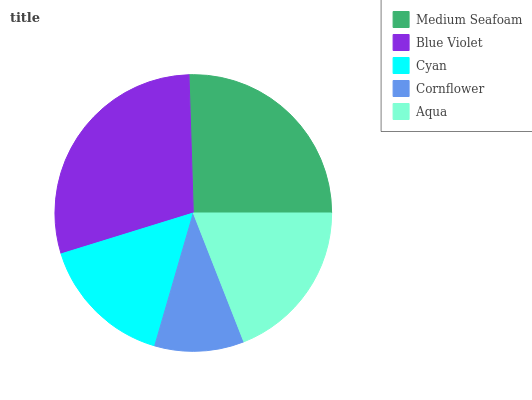Is Cornflower the minimum?
Answer yes or no. Yes. Is Blue Violet the maximum?
Answer yes or no. Yes. Is Cyan the minimum?
Answer yes or no. No. Is Cyan the maximum?
Answer yes or no. No. Is Blue Violet greater than Cyan?
Answer yes or no. Yes. Is Cyan less than Blue Violet?
Answer yes or no. Yes. Is Cyan greater than Blue Violet?
Answer yes or no. No. Is Blue Violet less than Cyan?
Answer yes or no. No. Is Aqua the high median?
Answer yes or no. Yes. Is Aqua the low median?
Answer yes or no. Yes. Is Medium Seafoam the high median?
Answer yes or no. No. Is Cornflower the low median?
Answer yes or no. No. 